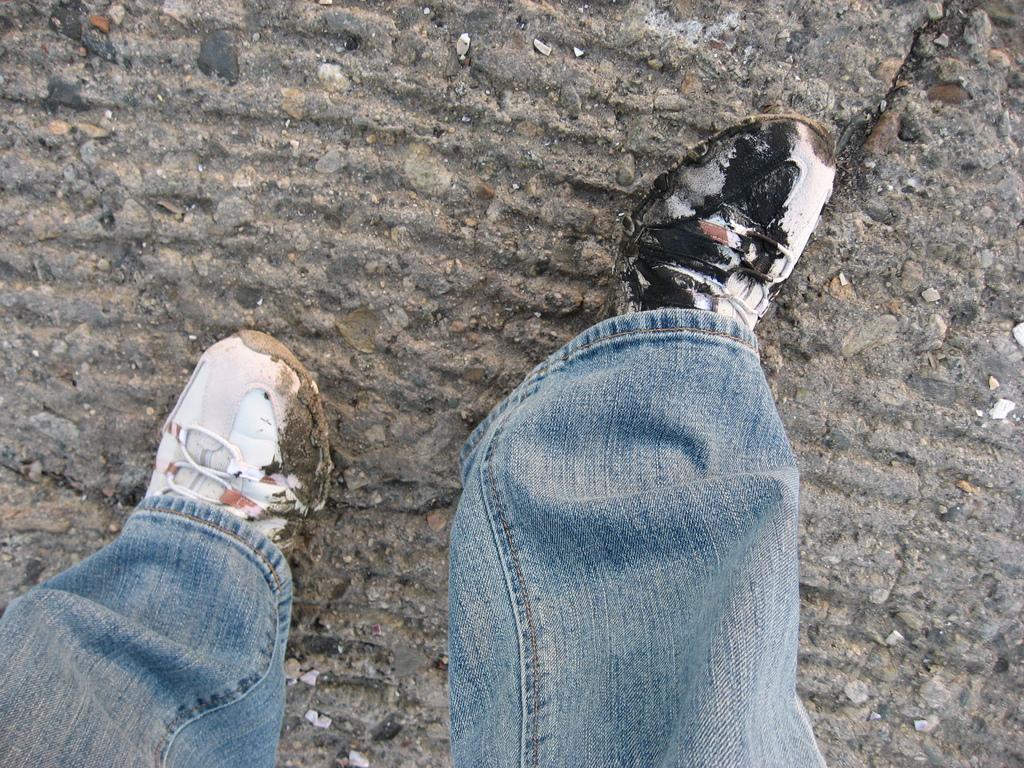Describe this image in one or two sentences. At the bottom of the image we can see the legs of a person with untidy shoes. At the top of the image there is a floor. 